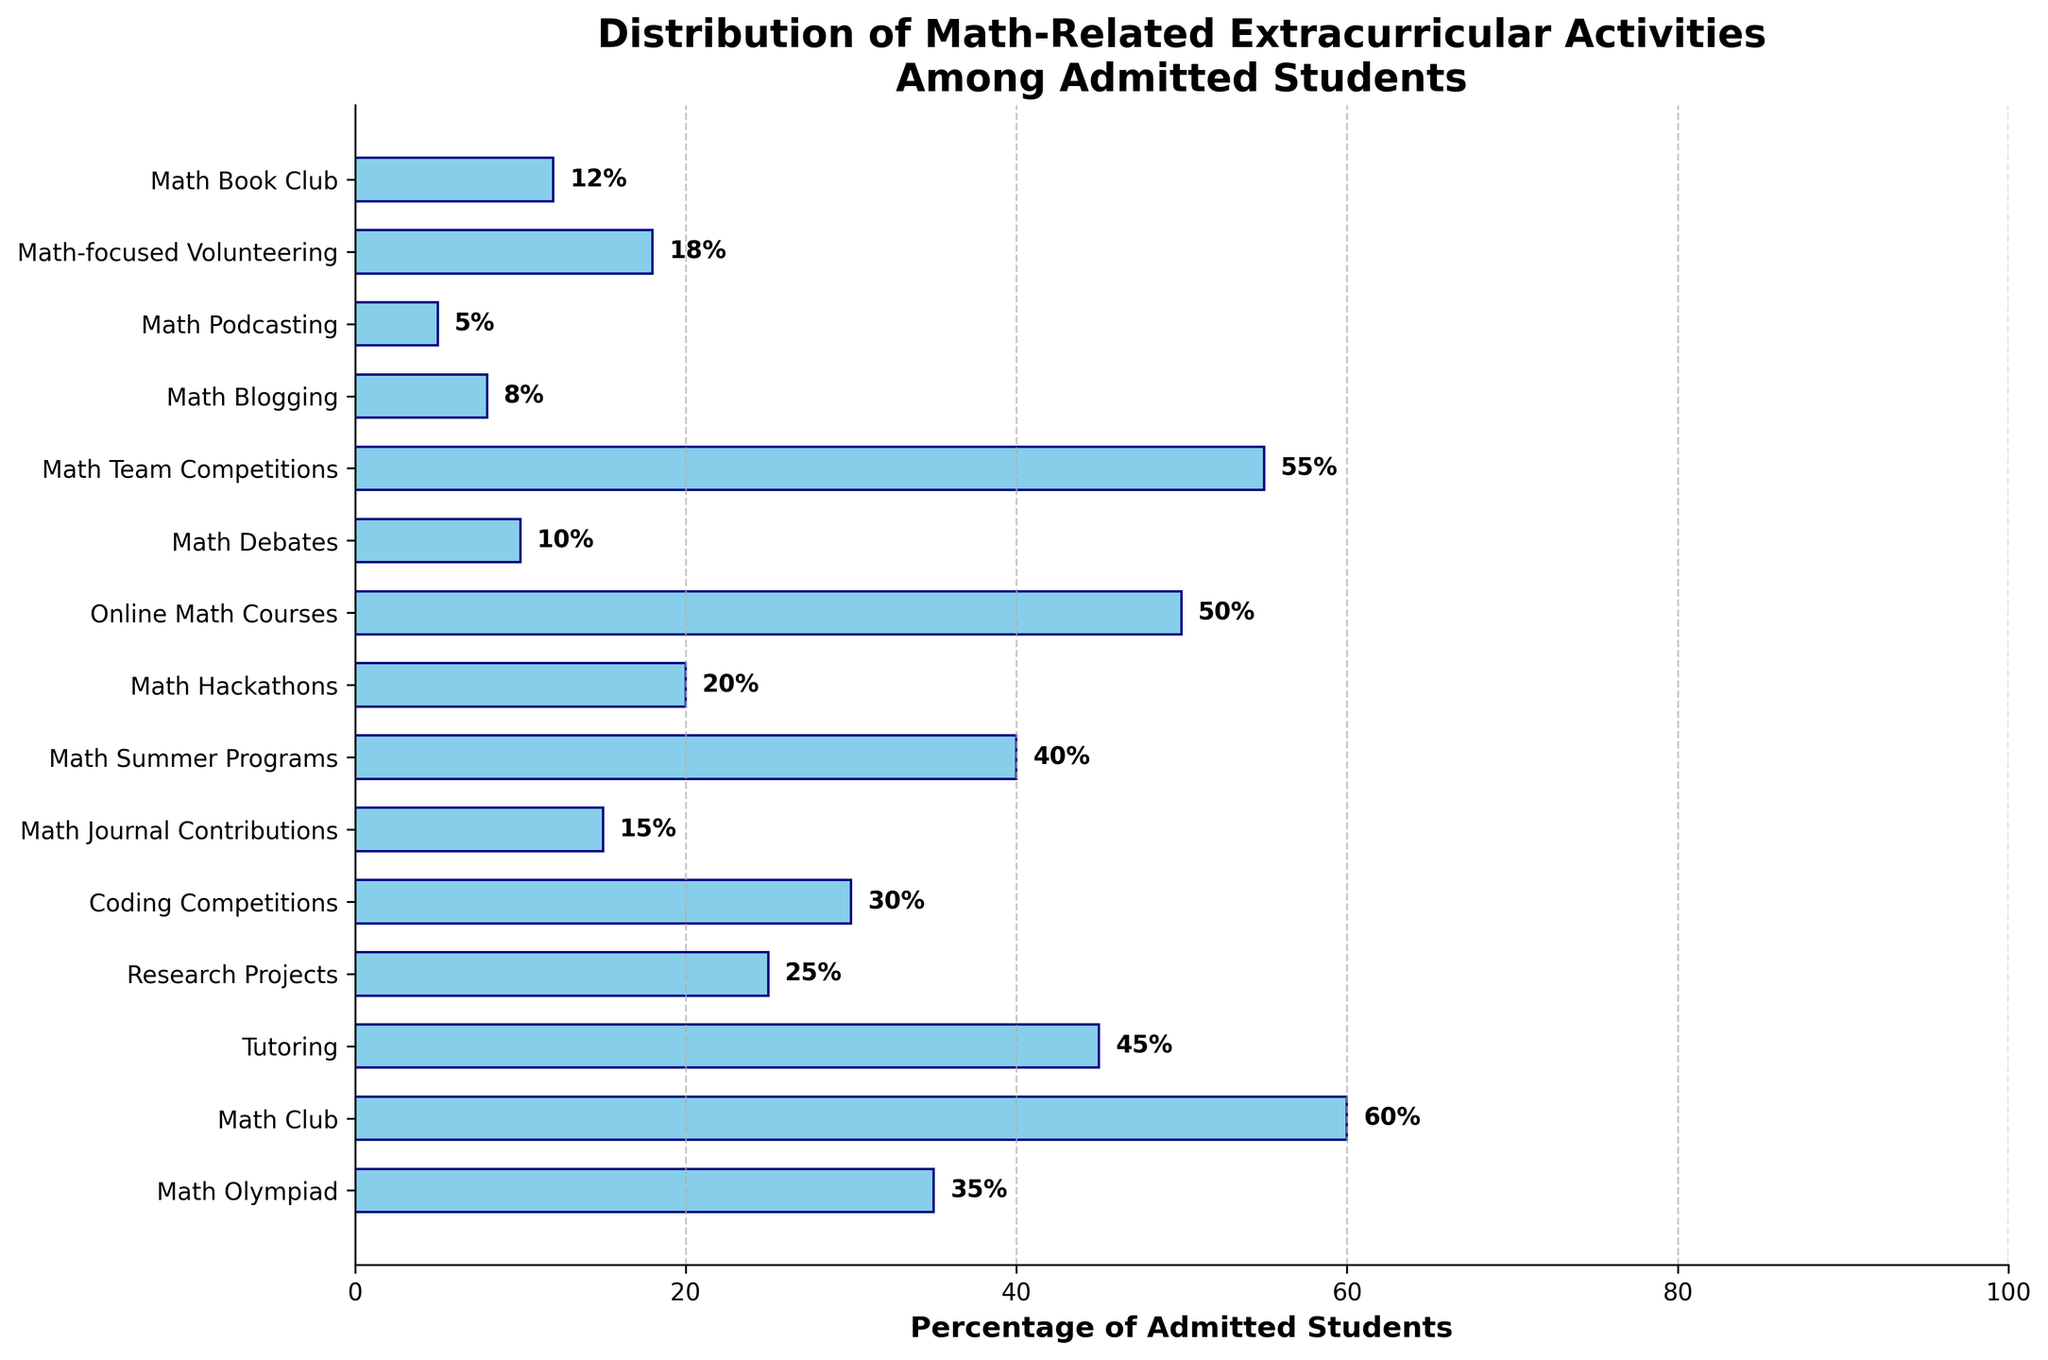Which math-related extracurricular activity has the highest percentage of admitted students? The bar chart shows the percentage of admitted students for each activity. The activity with the highest bar should be identified.
Answer: Math Club What is the combined percentage of students involved in Tutoring, Research Projects, and Math Journal Contributions? To find the combined percentage, sum the percentages of Tutoring, Research Projects, and Math Journal Contributions: 45% + 25% + 15% = 85%
Answer: 85% Which activity has a greater percentage of admissions, Online Math Courses or Coding Competitions? Compare the lengths of the bars for Online Math Courses and Coding Competitions: Online Math Courses has 50%, and Coding Competitions has 30%.
Answer: Online Math Courses How many activities have more than 40% of admitted students participating? Count the number of bars that exceed the 40% mark: Math Olympiad (35% is less than 40%), Math Club (60%), Tutoring (45%), Online Math Courses (50%), and Math Team Competitions (55%).
Answer: 4 Which activity has the smallest percentage of admitted students, and what is that percentage? Identify the shortest bar in the bar chart, which represents the activity with the smallest percentage. The Math Podcasting bar is the shortest with 5%.
Answer: Math Podcasting, 5% What is the difference in the percentage of admitted students between Math Team Competitions and Math Olympiad? Subtract the percentage of Math Olympiad from Math Team Competitions: 55% - 35% = 20%
Answer: 20% Compare the visual lengths of the bars for Math Summer Programs and Math Hackathons. Which is longer? The visual length of the bar for Math Summer Programs (40%) is longer than that for Math Hackathons (20%).
Answer: Math Summer Programs What is the average percentage of admitted students participating in Math-focused Volunteering, Math Book Club, and Math Debates? To find the average, sum the percentages of these activities and divide by the number of activities: (18% + 12% + 10%) / 3 = 40% / 3 = 13.33%
Answer: 13.33% How does the percentage for Math Blogging compare to that for Math Podcasting? Compare the bars for Math Blogging and Math Podcasting: Math Blogging (8%) is greater than Math Podcasting (5%).
Answer: Math Blogging is greater 